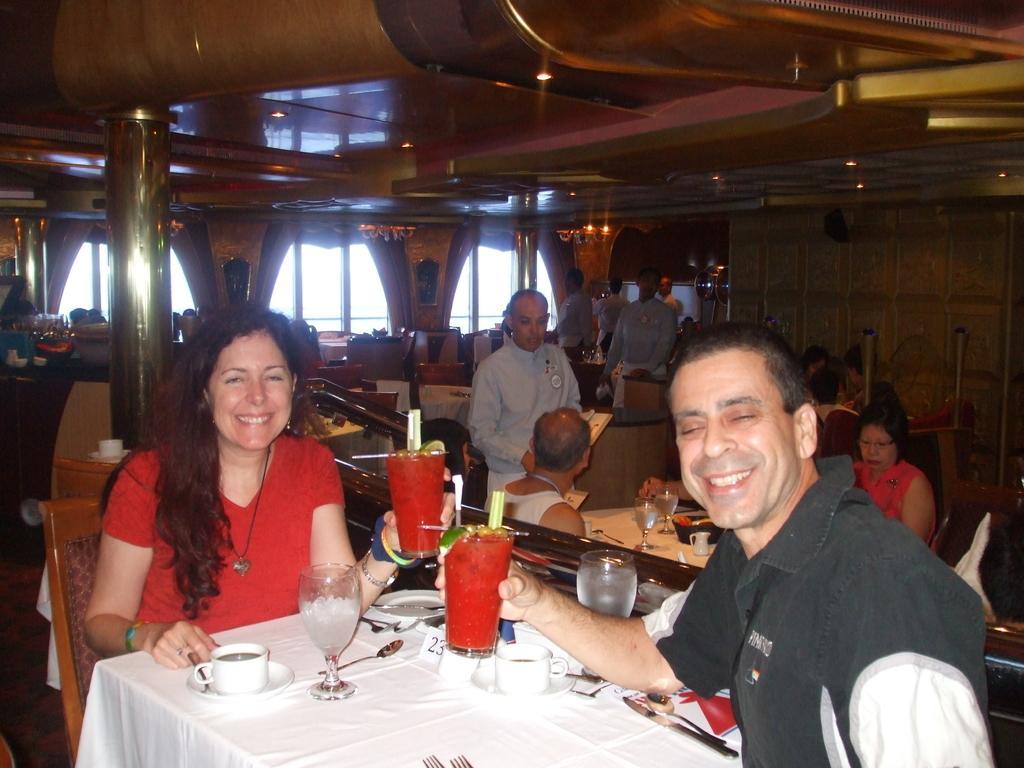Please provide a concise description of this image. In this image we can see some group of persons sitting around the tables in a restaurant, at the foreground of the image there are two persons wearing red and black color dress sitting on chairs holding two drinks in their hands and there are some spoons, forks, glasses, coffee cup on table and at the background of the image there are some persons standing and there are windows and curtains. 